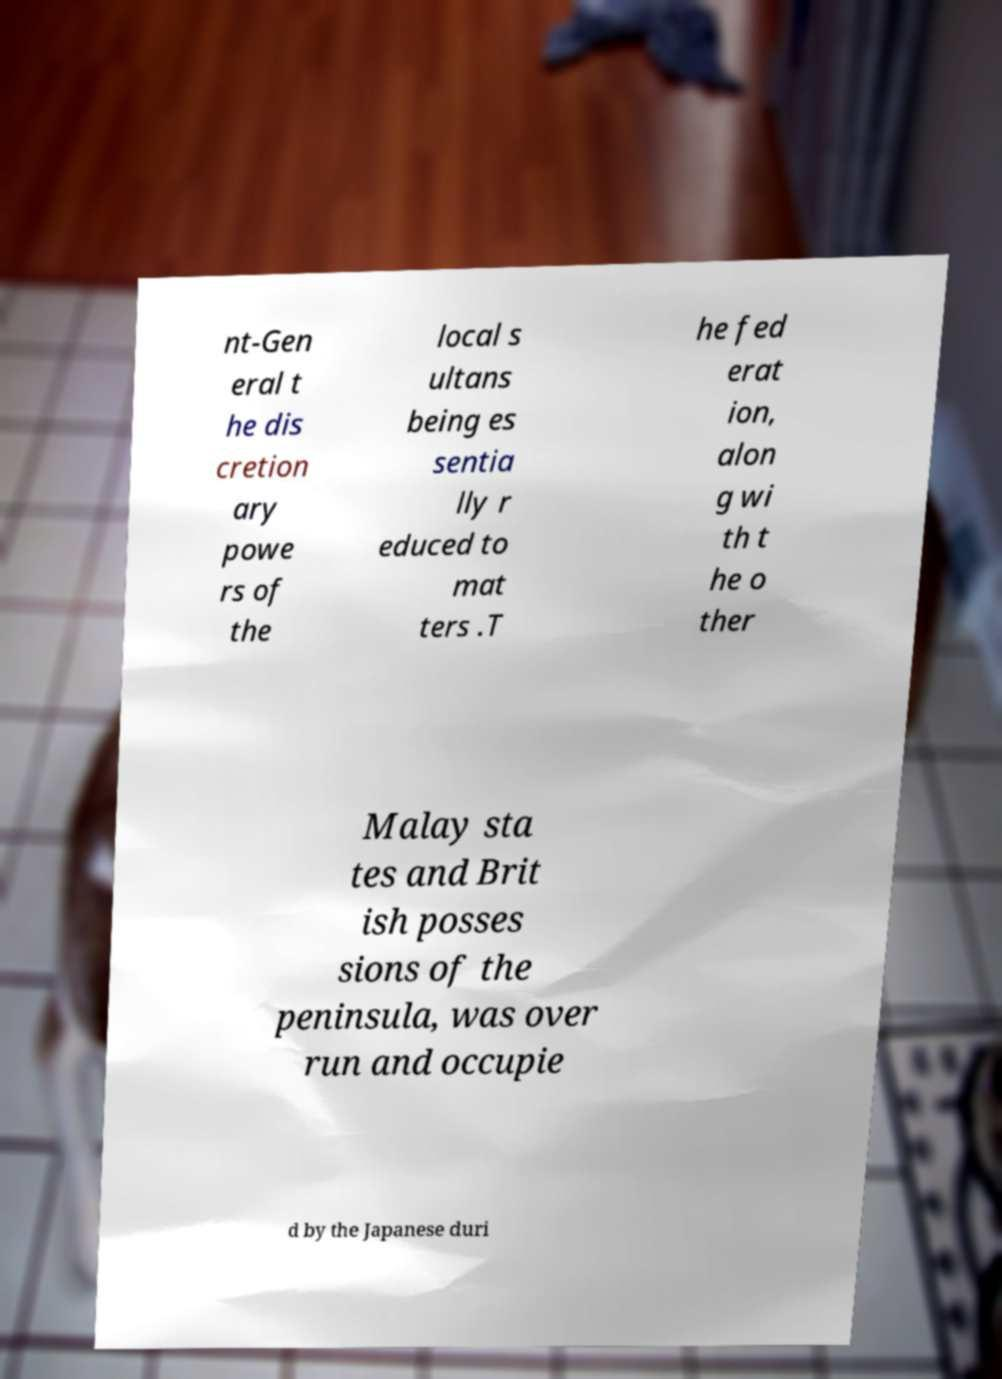There's text embedded in this image that I need extracted. Can you transcribe it verbatim? nt-Gen eral t he dis cretion ary powe rs of the local s ultans being es sentia lly r educed to mat ters .T he fed erat ion, alon g wi th t he o ther Malay sta tes and Brit ish posses sions of the peninsula, was over run and occupie d by the Japanese duri 